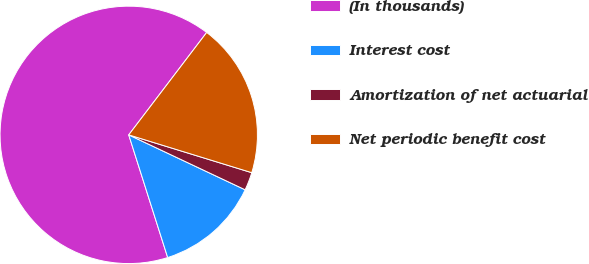Convert chart. <chart><loc_0><loc_0><loc_500><loc_500><pie_chart><fcel>(In thousands)<fcel>Interest cost<fcel>Amortization of net actuarial<fcel>Net periodic benefit cost<nl><fcel>65.24%<fcel>13.09%<fcel>2.27%<fcel>19.39%<nl></chart> 